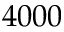Convert formula to latex. <formula><loc_0><loc_0><loc_500><loc_500>4 0 0 0</formula> 